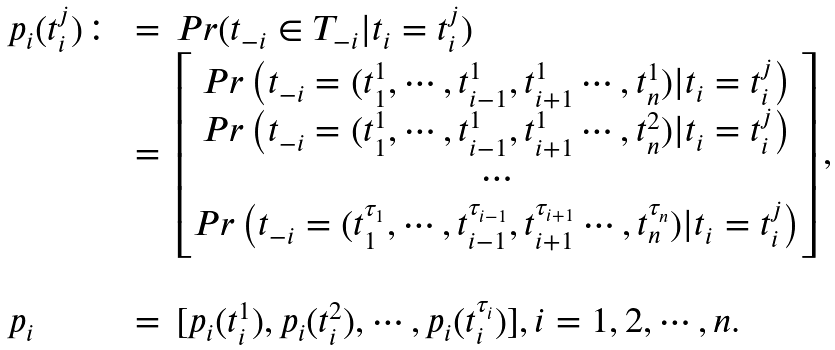Convert formula to latex. <formula><loc_0><loc_0><loc_500><loc_500>\begin{array} { l l l c c c } p _ { i } ( t _ { i } ^ { j } ) \colon & = & P r ( t _ { - i } \in T _ { - i } | t _ { i } = t _ { i } ^ { j } ) \\ & = & \begin{bmatrix} P r \left ( t _ { - i } = ( t _ { 1 } ^ { 1 } , \cdots , t _ { i - 1 } ^ { 1 } , t _ { i + 1 } ^ { 1 } \cdots , t _ { n } ^ { 1 } ) | t _ { i } = t _ { i } ^ { j } \right ) \\ P r \left ( t _ { - i } = ( t _ { 1 } ^ { 1 } , \cdots , t _ { i - 1 } ^ { 1 } , t _ { i + 1 } ^ { 1 } \cdots , t _ { n } ^ { 2 } ) | t _ { i } = t _ { i } ^ { j } \right ) \\ \cdots \\ P r \left ( t _ { - i } = ( t _ { 1 } ^ { \tau _ { 1 } } , \cdots , t _ { i - 1 } ^ { \tau _ { i - 1 } } , t _ { i + 1 } ^ { \tau _ { i + 1 } } \cdots , t _ { n } ^ { \tau _ { n } } ) | t _ { i } = t _ { i } ^ { j } \right ) \\ \end{bmatrix} , \\ & & \\ p _ { i } & = & [ p _ { i } ( t _ { i } ^ { 1 } ) , p _ { i } ( t _ { i } ^ { 2 } ) , \cdots , p _ { i } ( t _ { i } ^ { \tau _ { i } } ) ] , i = 1 , 2 , \cdots , n . \end{array}</formula> 